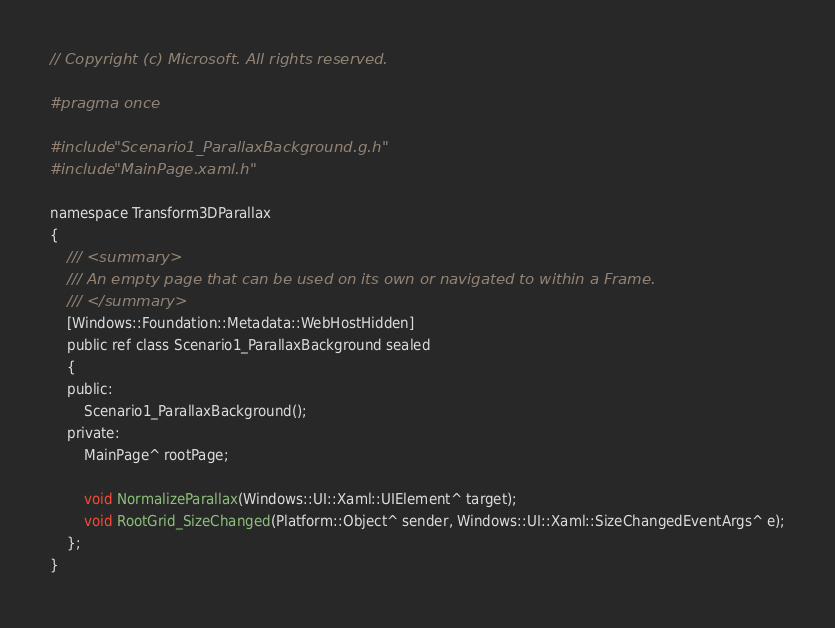Convert code to text. <code><loc_0><loc_0><loc_500><loc_500><_C_>// Copyright (c) Microsoft. All rights reserved.

#pragma once

#include "Scenario1_ParallaxBackground.g.h"
#include "MainPage.xaml.h"

namespace Transform3DParallax
{
    /// <summary>
    /// An empty page that can be used on its own or navigated to within a Frame.
    /// </summary>
    [Windows::Foundation::Metadata::WebHostHidden]
    public ref class Scenario1_ParallaxBackground sealed
    {
    public:
        Scenario1_ParallaxBackground();
    private:
        MainPage^ rootPage;

		void NormalizeParallax(Windows::UI::Xaml::UIElement^ target);
		void RootGrid_SizeChanged(Platform::Object^ sender, Windows::UI::Xaml::SizeChangedEventArgs^ e);
	};
}
</code> 